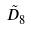<formula> <loc_0><loc_0><loc_500><loc_500>\tilde { D } _ { 8 }</formula> 